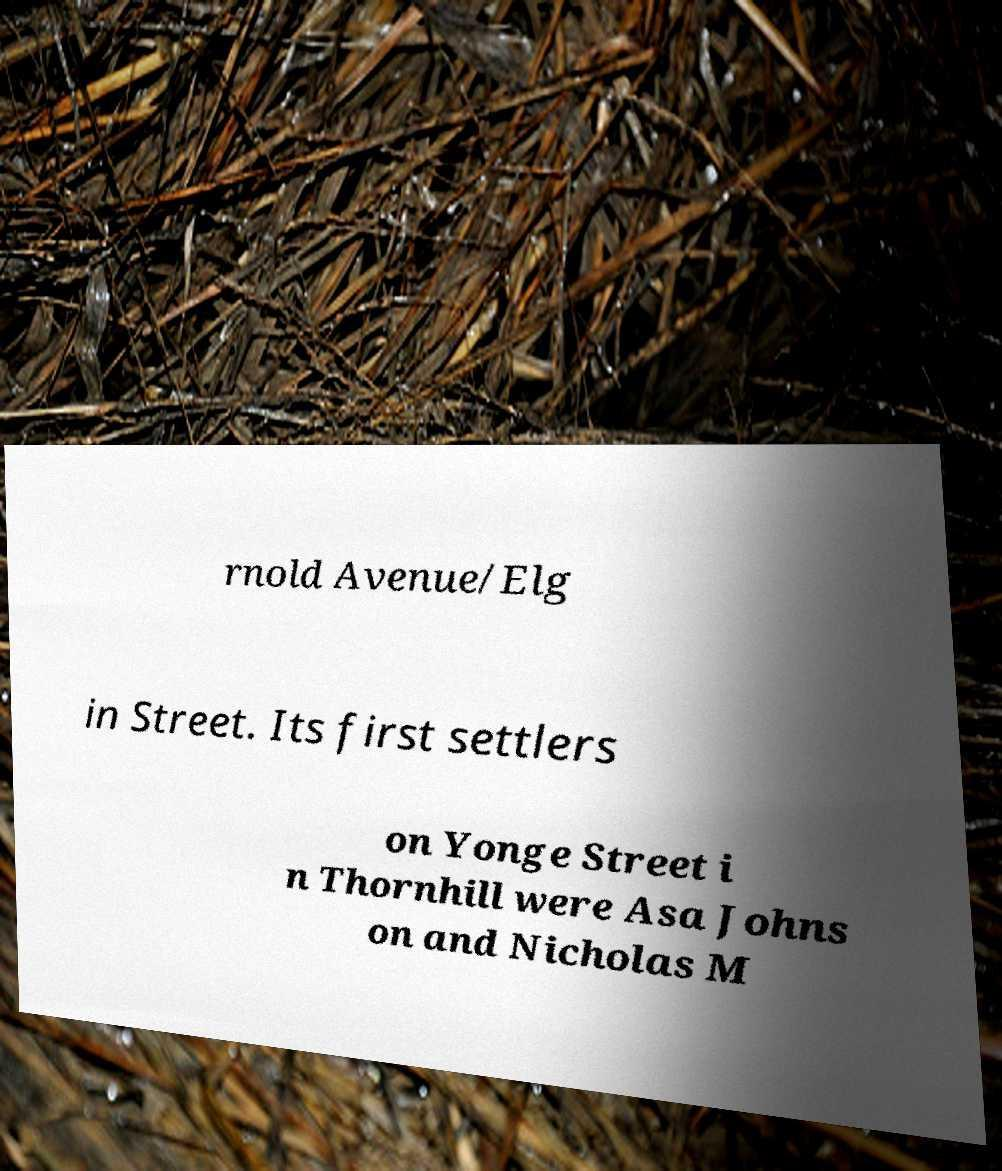Can you accurately transcribe the text from the provided image for me? rnold Avenue/Elg in Street. Its first settlers on Yonge Street i n Thornhill were Asa Johns on and Nicholas M 